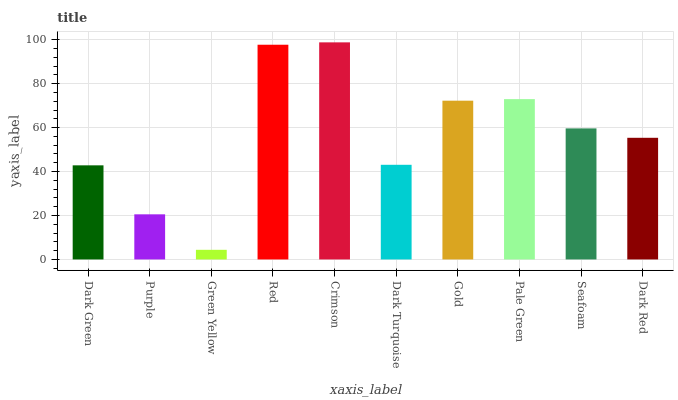Is Green Yellow the minimum?
Answer yes or no. Yes. Is Crimson the maximum?
Answer yes or no. Yes. Is Purple the minimum?
Answer yes or no. No. Is Purple the maximum?
Answer yes or no. No. Is Dark Green greater than Purple?
Answer yes or no. Yes. Is Purple less than Dark Green?
Answer yes or no. Yes. Is Purple greater than Dark Green?
Answer yes or no. No. Is Dark Green less than Purple?
Answer yes or no. No. Is Seafoam the high median?
Answer yes or no. Yes. Is Dark Red the low median?
Answer yes or no. Yes. Is Green Yellow the high median?
Answer yes or no. No. Is Red the low median?
Answer yes or no. No. 